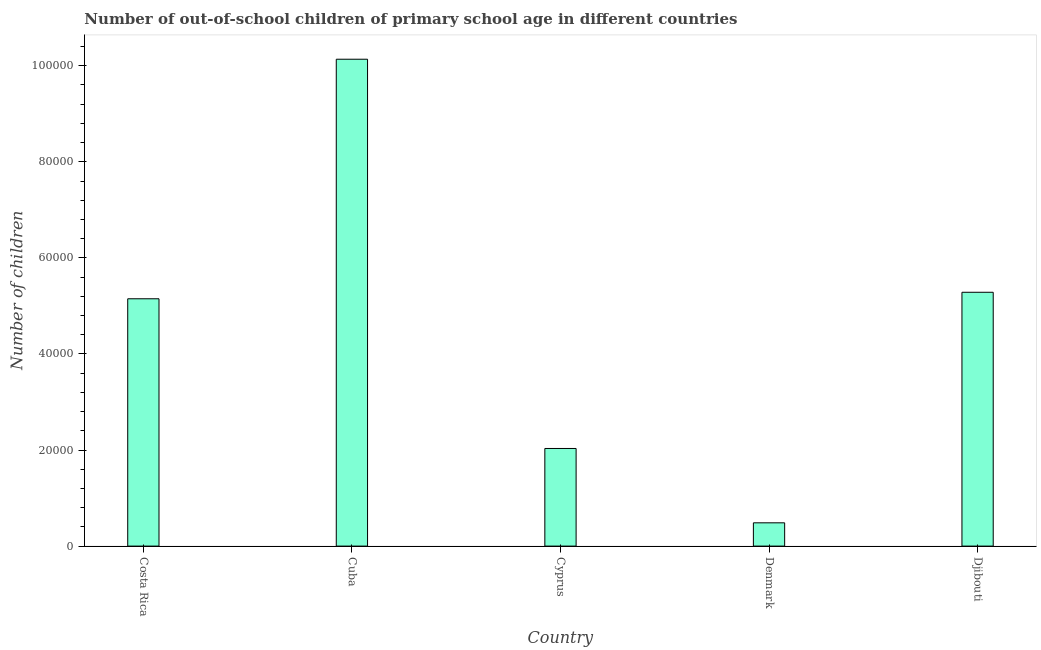Does the graph contain any zero values?
Ensure brevity in your answer.  No. Does the graph contain grids?
Offer a very short reply. No. What is the title of the graph?
Your response must be concise. Number of out-of-school children of primary school age in different countries. What is the label or title of the X-axis?
Ensure brevity in your answer.  Country. What is the label or title of the Y-axis?
Your answer should be very brief. Number of children. What is the number of out-of-school children in Denmark?
Keep it short and to the point. 4846. Across all countries, what is the maximum number of out-of-school children?
Ensure brevity in your answer.  1.01e+05. Across all countries, what is the minimum number of out-of-school children?
Keep it short and to the point. 4846. In which country was the number of out-of-school children maximum?
Your response must be concise. Cuba. What is the sum of the number of out-of-school children?
Give a very brief answer. 2.31e+05. What is the difference between the number of out-of-school children in Cuba and Cyprus?
Your answer should be very brief. 8.10e+04. What is the average number of out-of-school children per country?
Provide a short and direct response. 4.62e+04. What is the median number of out-of-school children?
Ensure brevity in your answer.  5.15e+04. What is the ratio of the number of out-of-school children in Cuba to that in Cyprus?
Give a very brief answer. 4.99. Is the number of out-of-school children in Costa Rica less than that in Djibouti?
Your response must be concise. Yes. What is the difference between the highest and the second highest number of out-of-school children?
Your response must be concise. 4.85e+04. Is the sum of the number of out-of-school children in Cyprus and Djibouti greater than the maximum number of out-of-school children across all countries?
Your answer should be compact. No. What is the difference between the highest and the lowest number of out-of-school children?
Make the answer very short. 9.65e+04. What is the difference between two consecutive major ticks on the Y-axis?
Make the answer very short. 2.00e+04. Are the values on the major ticks of Y-axis written in scientific E-notation?
Provide a succinct answer. No. What is the Number of children of Costa Rica?
Provide a short and direct response. 5.15e+04. What is the Number of children in Cuba?
Offer a terse response. 1.01e+05. What is the Number of children in Cyprus?
Provide a succinct answer. 2.03e+04. What is the Number of children in Denmark?
Provide a short and direct response. 4846. What is the Number of children of Djibouti?
Your answer should be very brief. 5.28e+04. What is the difference between the Number of children in Costa Rica and Cuba?
Your answer should be very brief. -4.99e+04. What is the difference between the Number of children in Costa Rica and Cyprus?
Make the answer very short. 3.12e+04. What is the difference between the Number of children in Costa Rica and Denmark?
Ensure brevity in your answer.  4.66e+04. What is the difference between the Number of children in Costa Rica and Djibouti?
Your response must be concise. -1353. What is the difference between the Number of children in Cuba and Cyprus?
Your response must be concise. 8.10e+04. What is the difference between the Number of children in Cuba and Denmark?
Your answer should be compact. 9.65e+04. What is the difference between the Number of children in Cuba and Djibouti?
Offer a very short reply. 4.85e+04. What is the difference between the Number of children in Cyprus and Denmark?
Your response must be concise. 1.55e+04. What is the difference between the Number of children in Cyprus and Djibouti?
Ensure brevity in your answer.  -3.25e+04. What is the difference between the Number of children in Denmark and Djibouti?
Provide a short and direct response. -4.80e+04. What is the ratio of the Number of children in Costa Rica to that in Cuba?
Give a very brief answer. 0.51. What is the ratio of the Number of children in Costa Rica to that in Cyprus?
Offer a very short reply. 2.53. What is the ratio of the Number of children in Costa Rica to that in Denmark?
Your answer should be compact. 10.62. What is the ratio of the Number of children in Cuba to that in Cyprus?
Your answer should be very brief. 4.99. What is the ratio of the Number of children in Cuba to that in Denmark?
Your answer should be compact. 20.92. What is the ratio of the Number of children in Cuba to that in Djibouti?
Your answer should be very brief. 1.92. What is the ratio of the Number of children in Cyprus to that in Denmark?
Your answer should be very brief. 4.19. What is the ratio of the Number of children in Cyprus to that in Djibouti?
Ensure brevity in your answer.  0.39. What is the ratio of the Number of children in Denmark to that in Djibouti?
Ensure brevity in your answer.  0.09. 